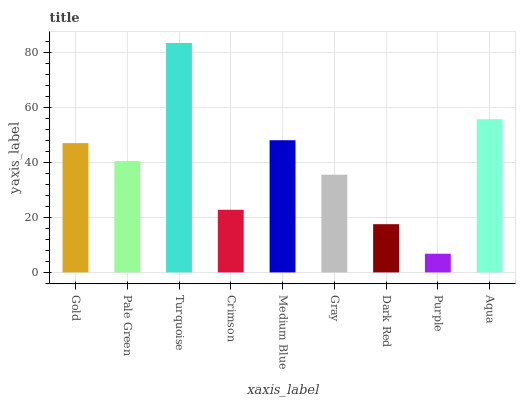Is Purple the minimum?
Answer yes or no. Yes. Is Turquoise the maximum?
Answer yes or no. Yes. Is Pale Green the minimum?
Answer yes or no. No. Is Pale Green the maximum?
Answer yes or no. No. Is Gold greater than Pale Green?
Answer yes or no. Yes. Is Pale Green less than Gold?
Answer yes or no. Yes. Is Pale Green greater than Gold?
Answer yes or no. No. Is Gold less than Pale Green?
Answer yes or no. No. Is Pale Green the high median?
Answer yes or no. Yes. Is Pale Green the low median?
Answer yes or no. Yes. Is Turquoise the high median?
Answer yes or no. No. Is Medium Blue the low median?
Answer yes or no. No. 